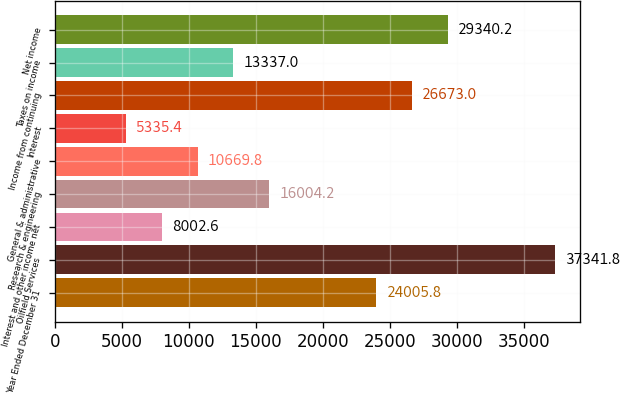Convert chart to OTSL. <chart><loc_0><loc_0><loc_500><loc_500><bar_chart><fcel>Year Ended December 31<fcel>Oilfield Services<fcel>Interest and other income net<fcel>Research & engineering<fcel>General & administrative<fcel>Interest<fcel>Income from continuing<fcel>Taxes on income<fcel>Net income<nl><fcel>24005.8<fcel>37341.8<fcel>8002.6<fcel>16004.2<fcel>10669.8<fcel>5335.4<fcel>26673<fcel>13337<fcel>29340.2<nl></chart> 